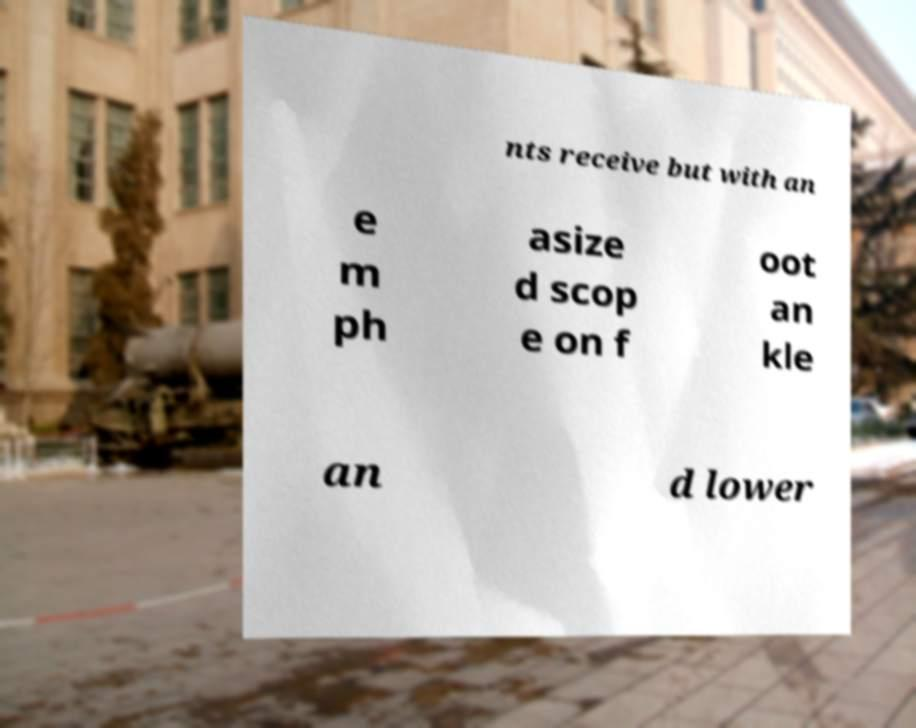I need the written content from this picture converted into text. Can you do that? nts receive but with an e m ph asize d scop e on f oot an kle an d lower 